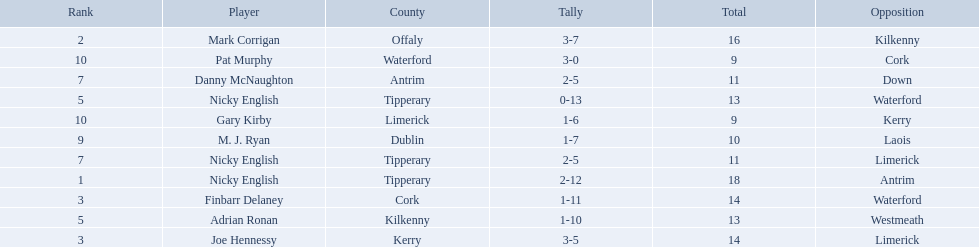What numbers are in the total column? 18, 16, 14, 14, 13, 13, 11, 11, 10, 9, 9. What row has the number 10 in the total column? 9, M. J. Ryan, Dublin, 1-7, 10, Laois. What name is in the player column for this row? M. J. Ryan. 